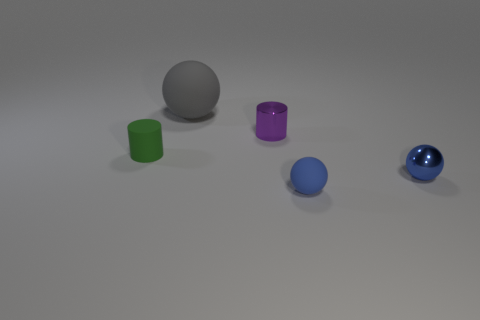Subtract 1 spheres. How many spheres are left? 2 Add 2 blue metallic balls. How many objects exist? 7 Subtract all brown cylinders. Subtract all tiny green rubber objects. How many objects are left? 4 Add 1 matte objects. How many matte objects are left? 4 Add 3 tiny things. How many tiny things exist? 7 Subtract 1 purple cylinders. How many objects are left? 4 Subtract all spheres. How many objects are left? 2 